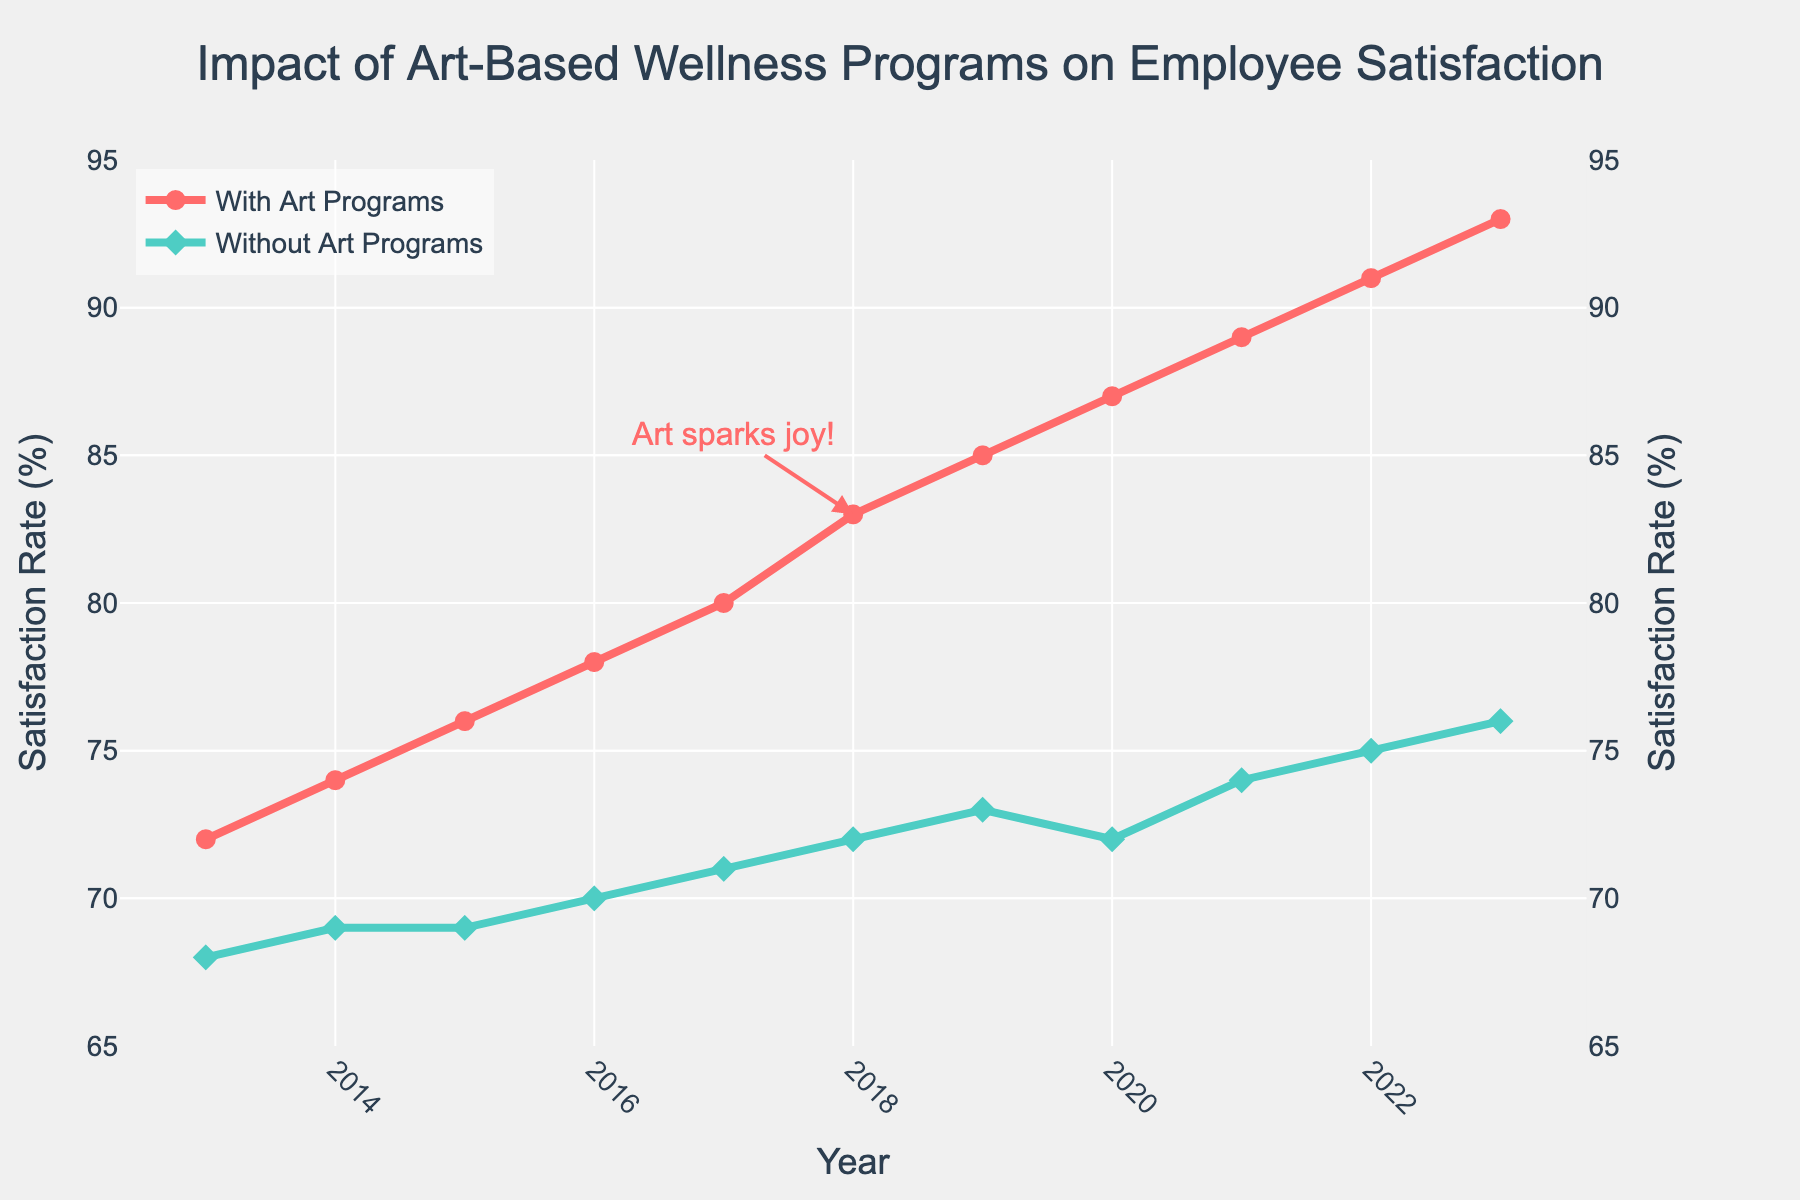What is the trend in employee satisfaction rates for companies with art programs over the last decade? To determine the trend, look at the line representing "With Art Programs" over the years. The line shows a steady upwards trajectory from 2013 (72%) to 2023 (93%).
Answer: Upward trend What is the difference in employee satisfaction rates between companies with and without art programs in 2023? In 2023, the satisfaction rate for "With Art Programs" is 93%, and for "Without Art Programs" it is 76%. Subtract 76 from 93 to find the difference.
Answer: 17% How much did employee satisfaction rates increase for companies without art programs from 2013 to 2023? In 2013, the satisfaction rate for "Without Art Programs" is 68%, and in 2023 it is 76%. Subtract 68 from 76 to find the increase.
Answer: 8% Which year marked the largest difference in satisfaction rates between companies with and without art programs? To find this, look at the differences each year: 2013 (4%), 2014 (5%), 2015 (7%), 2016 (8%), 2017 (9%), 2018 (11%), 2019 (12%), 2020 (15%), 2021 (15%), 2022 (16%), 2023 (17%). The largest difference is in 2023, with 17%.
Answer: 2023 What is the average employee satisfaction rate for companies with art programs from 2013 to 2023? Sum the satisfaction rates for "With Art Programs" for each year and divide by the number of years: (72+74+76+78+80+83+85+87+89+91+93) / 11. The sum is 908, and dividing by 11 gives approximately 82.55%.
Answer: 82.55% How did the satisfaction rate for companies without art programs change from 2019 to 2020? In 2019, the satisfaction rate for "Without Art Programs" is 73%, and in 2020 it is 72%. The difference is 73 - 72.
Answer: -1% Which line has the annotation saying "Art sparks joy!"? Look at the annotation on the chart. The annotation "Art sparks joy!" is placed near the "With Art Programs" line at the point for 2018.
Answer: With Art Programs Did companies with art programs ever experience a decrease in employee satisfaction rates over the last decade? Examine the line for "With Art Programs". It shows a consistently upward trend with no decreases from 2013 to 2023.
Answer: No In what year did both companies with and without art programs have the closest satisfaction rates? The smallest difference over the years is found by comparing the values. The closest gap is in 2014, where "With Art Programs" is 74% and "Without Art Programs" is 69%. The difference is 5%.
Answer: 2014 